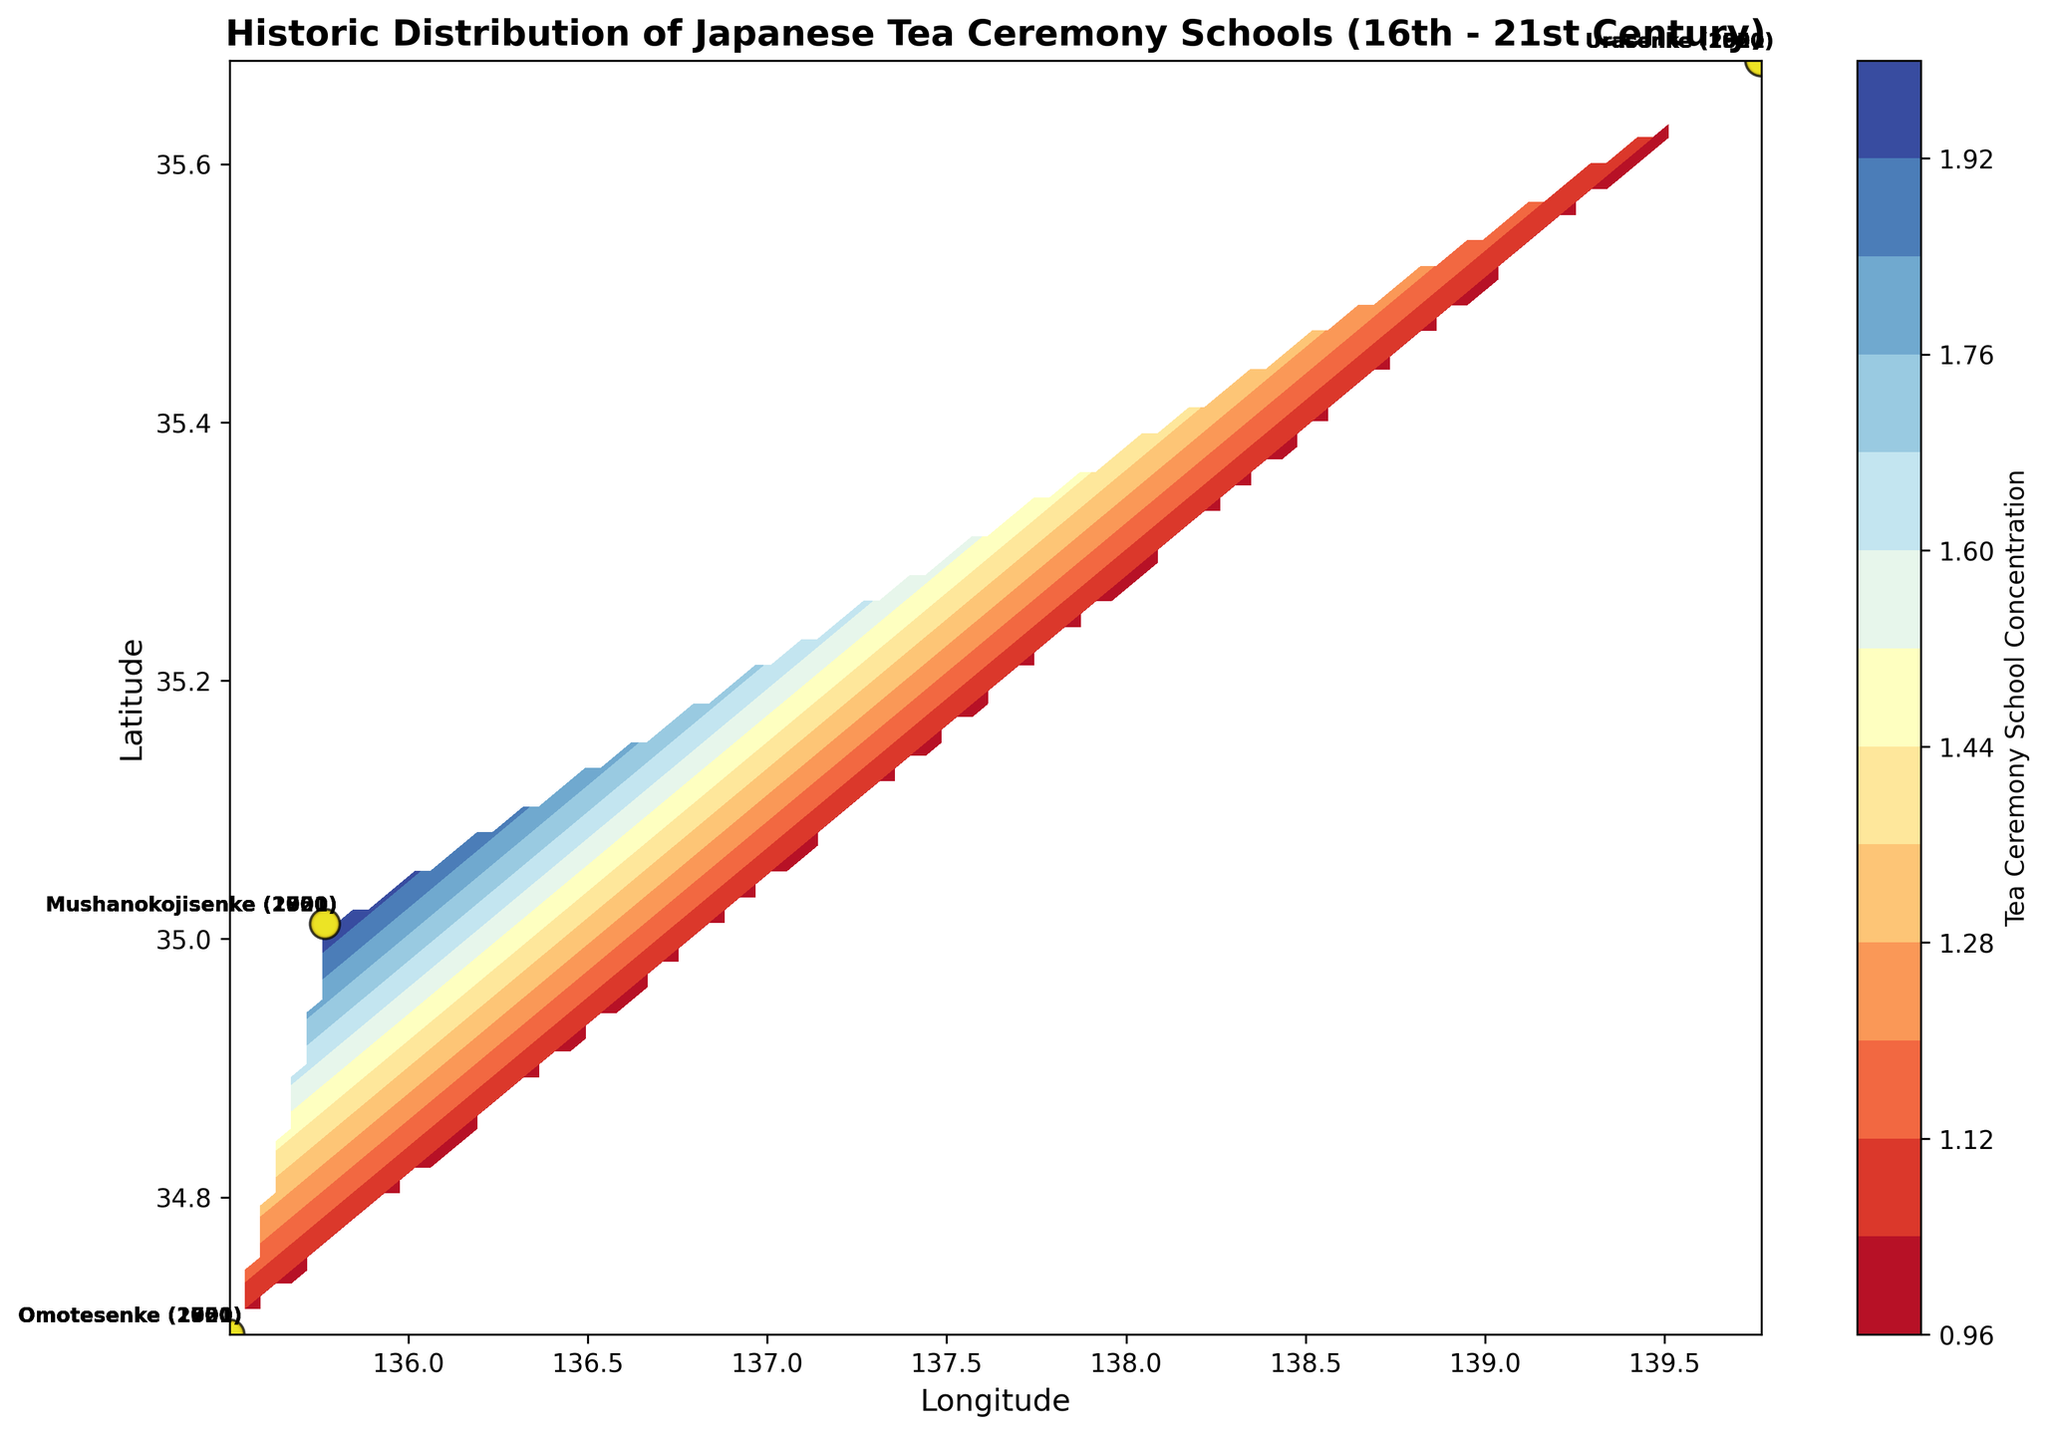What is the general trend in the concentration of tea ceremony schools over time? By looking at the scatter plot, you can observe the relative sizes of the markers for each time period. Over time (from 1550 to 2021), the size of the markers, which indicates the concentration, tends to increase for all schools.
Answer: Increasing Which city had the highest concentration of tea ceremony schools in the year 2000? Evaluate the scatter plot to see which city (markers) had the largest size in the year 2000. The largest concentration is indicated by Tokyo (Urasenke) with the biggest marker.
Answer: Tokyo Between the years 1600 and 1800, which school shows the greatest increase in concentration? Compare the marker sizes of each school between 1600 and 1800. For Urasenke, Tokyo goes from 3 to 2 (+1); for Omotesenke, Osaka goes from 2 to 3 (+1); for Mushanokojisenke, Kyoto goes from 2 to 3 (+1). While they all increase, none shows a markedly higher increase than another.
Answer: All schools (equal increase) What is the trend in the concentration levels of Urasenke from 1550 to 2021? Look at the Urasenke markers in Tokyo to track the changes in marker size over the years—1550, 1600, 1800, 1900, 1950, 2000, and 2021. The sizes gradually increase, indicating a rising trend.
Answer: Rising Which city is represented by the most diverse tea ceremony schools over the centuries? Check the annotations to see which city has markers for the most different schools (Urasenke, Omotesenke, Mushanokojisenke). Kyoto (lat 35.0116, long 135.7681) has markers for Omotesenke and Mushanokojisenke over several periods.
Answer: Kyoto How many schools are at their highest concentration levels in 2021? Compare the marker sizes for each city in 2021 and the earlier years. All three schools (Urasenke in Tokyo, Omotesenke in Osaka, and Mushanokojisenke in Kyoto) have their largest markers in 2021.
Answer: Three Which school had the fastest rise in concentration between the year 1950 and 2000? Compare the marker sizes of each school between 1950 and 2000. The sizes incrementally increase for Urasenke (+1), Omotesenke (+1), and Mushanokojisenke (+1). No school has a particularly faster rise than the others.
Answer: All schools (equal rise) Which city had a constant presence of tea ceremony schools from 1550 to 2021? Review the cities marked over all the years. Tokyo (Urasenke) and Osaka (Omotesenke) have markers in every period from 1550 to 2021.
Answer: Tokyo, Osaka 